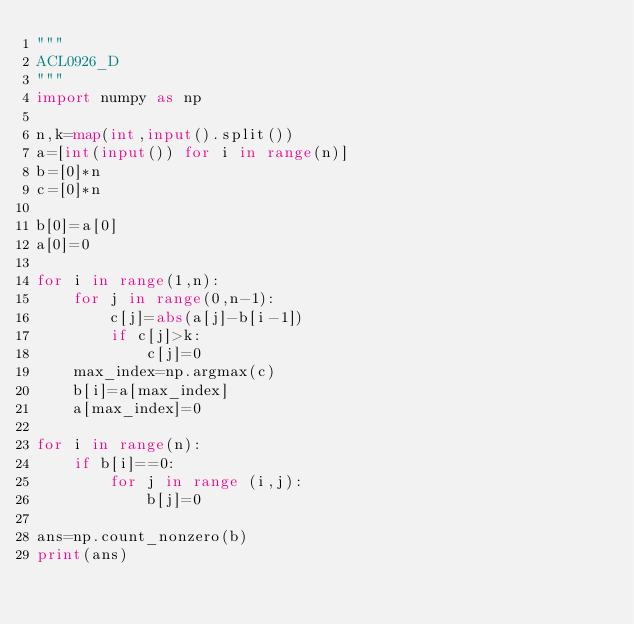Convert code to text. <code><loc_0><loc_0><loc_500><loc_500><_Python_>"""
ACL0926_D
"""
import numpy as np

n,k=map(int,input().split())
a=[int(input()) for i in range(n)]
b=[0]*n
c=[0]*n

b[0]=a[0]
a[0]=0

for i in range(1,n):
    for j in range(0,n-1):
        c[j]=abs(a[j]-b[i-1])
        if c[j]>k:
            c[j]=0
    max_index=np.argmax(c)
    b[i]=a[max_index]
    a[max_index]=0

for i in range(n):
    if b[i]==0:
        for j in range (i,j):
            b[j]=0
            
ans=np.count_nonzero(b)
print(ans)</code> 